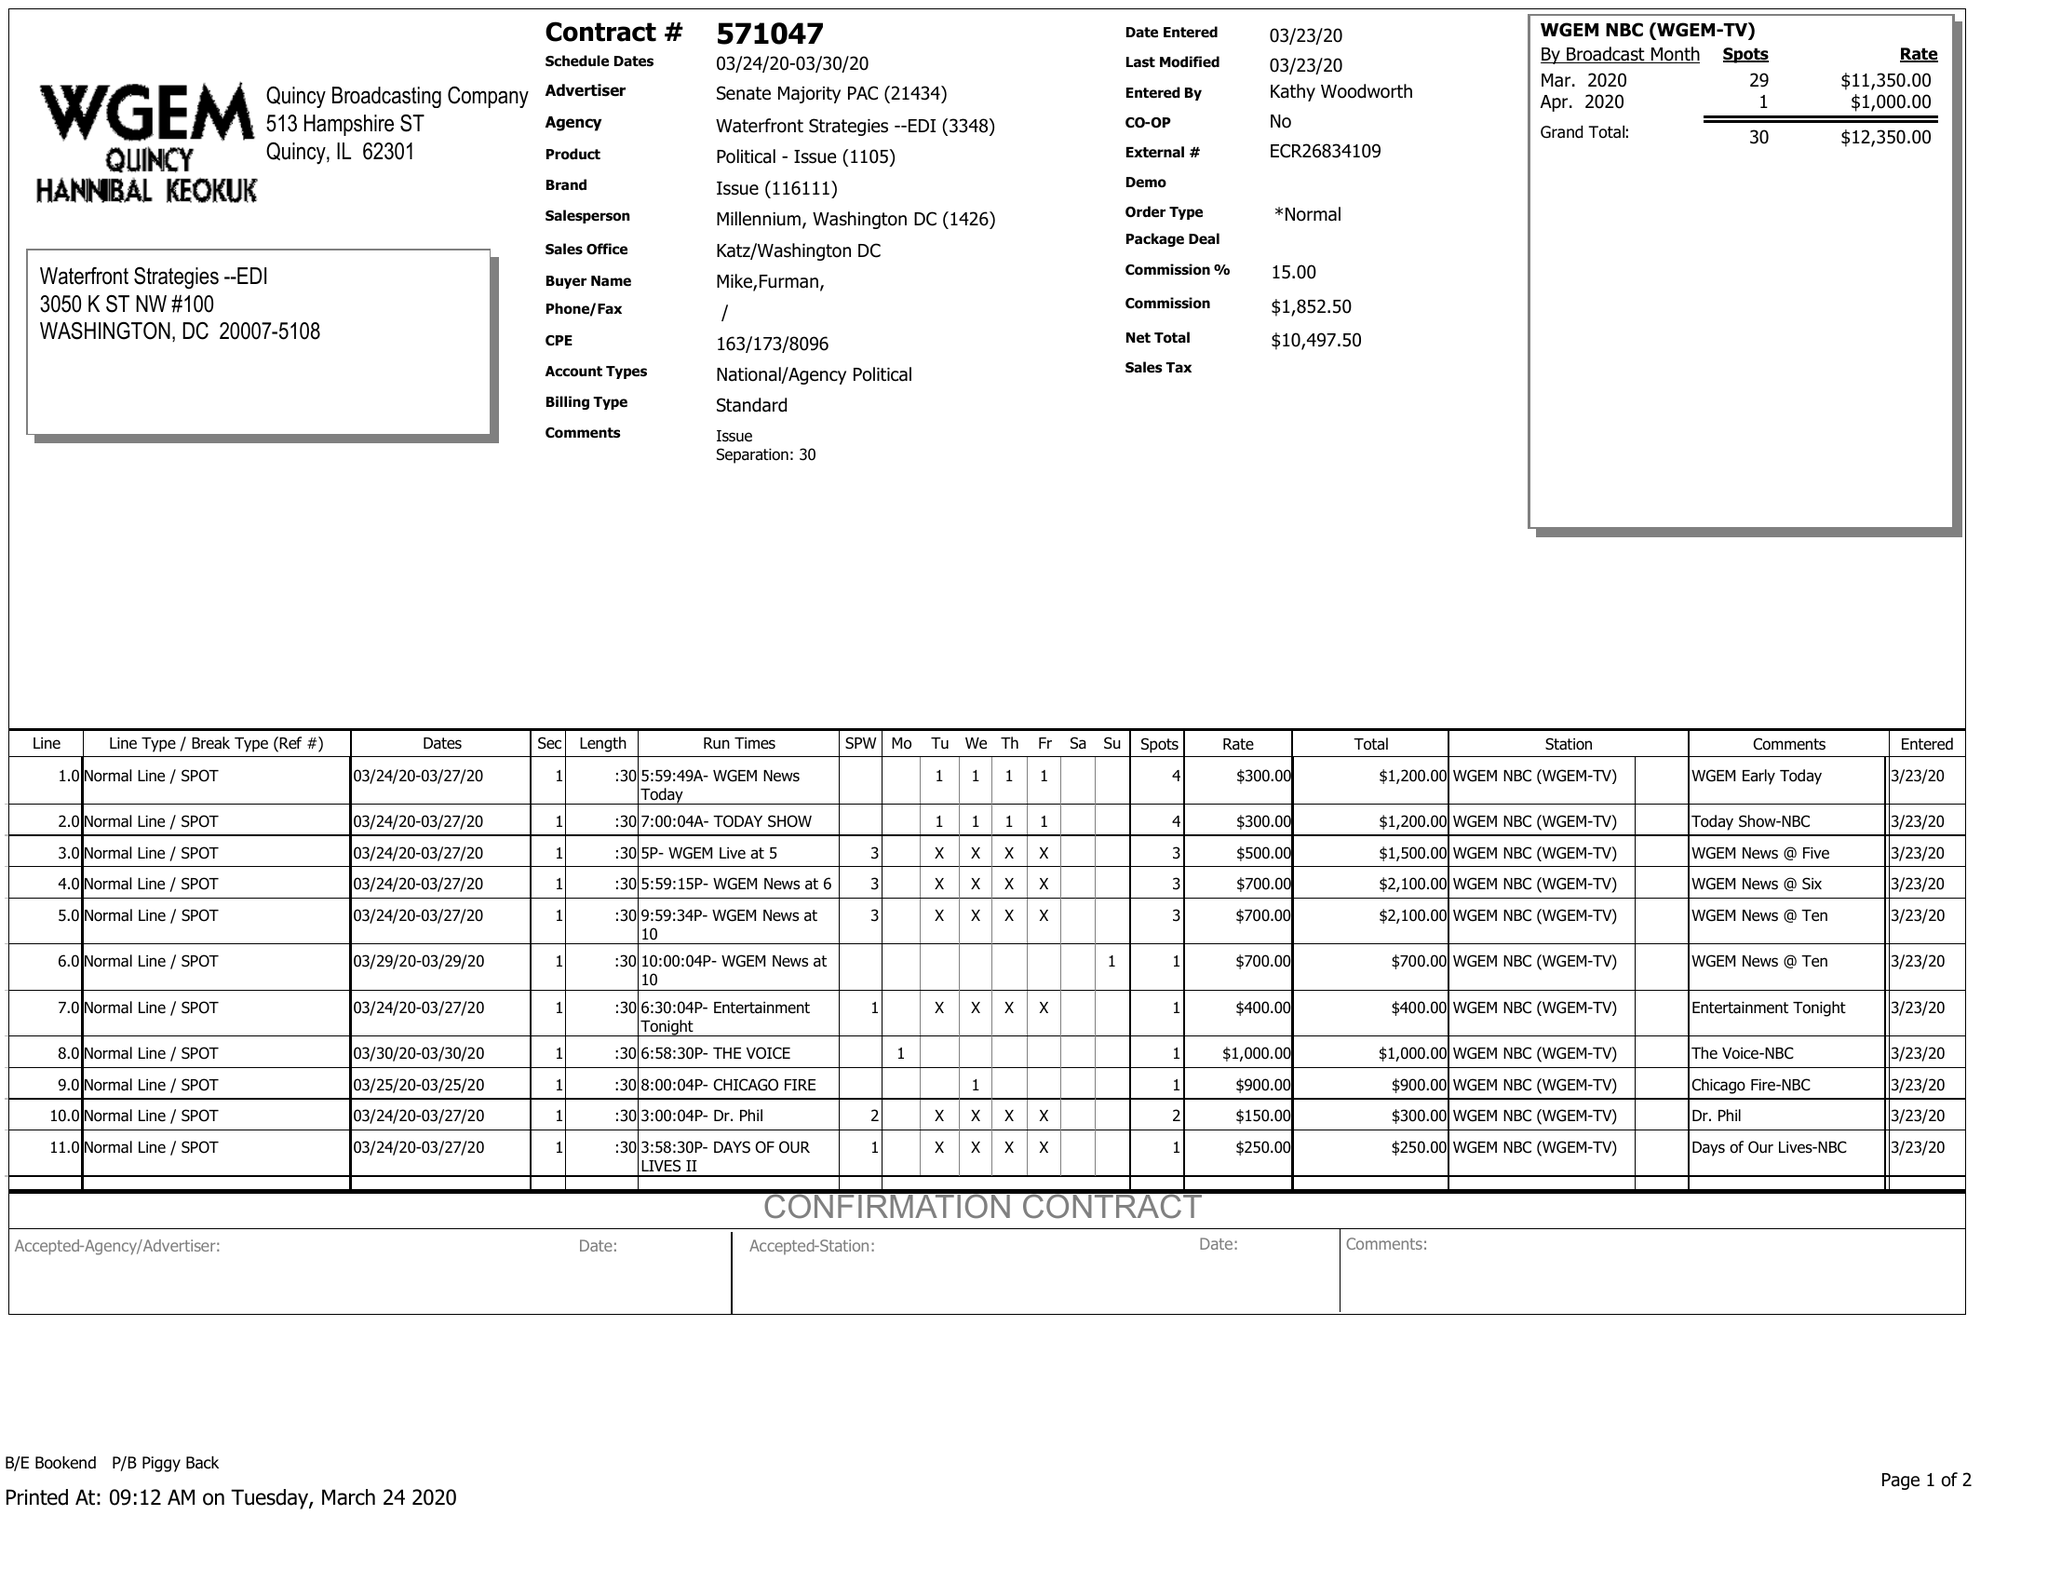What is the value for the advertiser?
Answer the question using a single word or phrase. SENATE MAJORITY PAC 